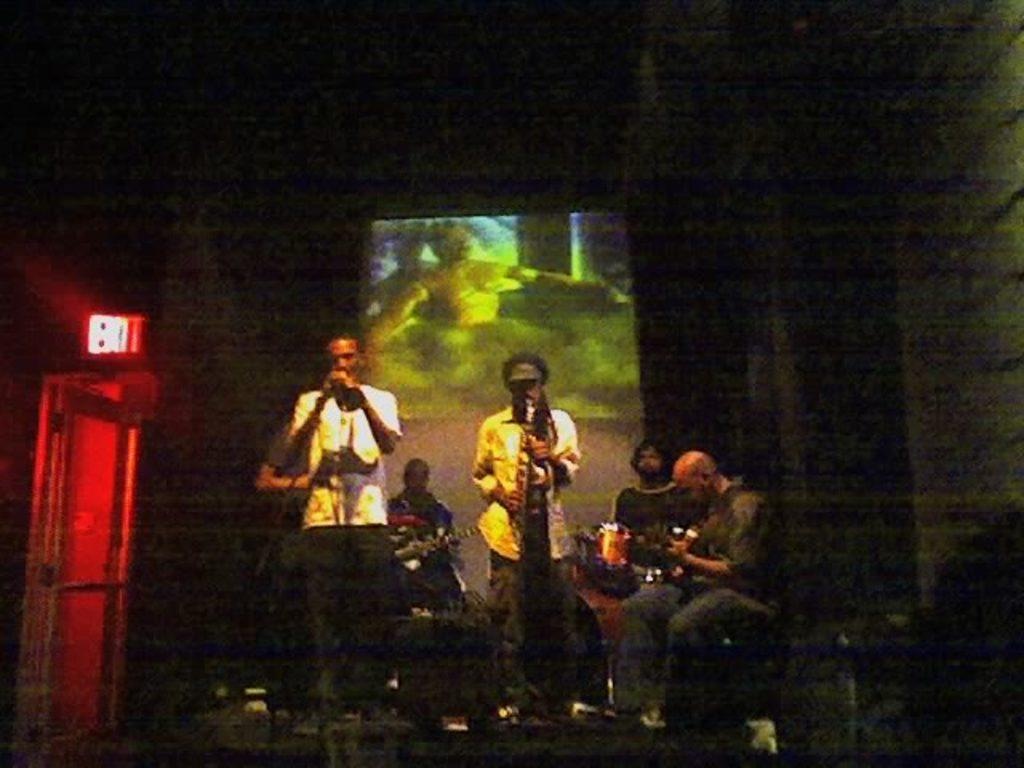What are the people in the image doing? The people in the image are playing musical instruments. What can be seen in the background of the image? There is a projector screen in the background. Is there a way for people to leave the area in the image? Yes, there is an exit visible in the image. What type of mist can be seen surrounding the people playing musical instruments in the image? There is no mist present in the image; the people are playing musical instruments in a clear environment. Can you tell me how many pigs are visible on the projector screen in the image? There are no pigs visible on the projector screen in the image; it is a screen in the background, and no animals are depicted. 